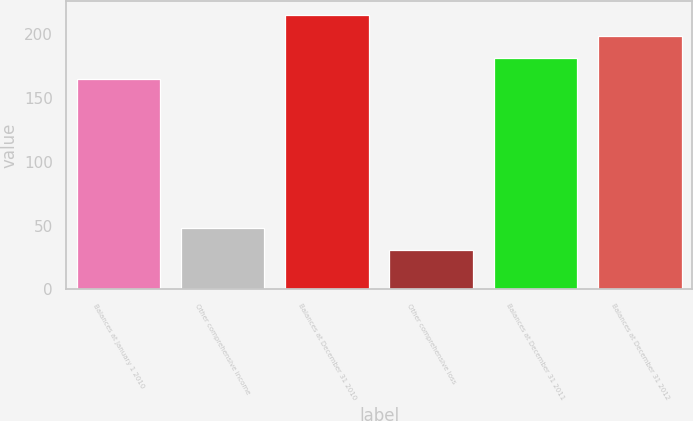Convert chart to OTSL. <chart><loc_0><loc_0><loc_500><loc_500><bar_chart><fcel>Balances at January 1 2010<fcel>Other comprehensive income<fcel>Balances at December 31 2010<fcel>Other comprehensive loss<fcel>Balances at December 31 2011<fcel>Balances at December 31 2012<nl><fcel>164.5<fcel>47.72<fcel>214.66<fcel>31<fcel>181.22<fcel>197.94<nl></chart> 